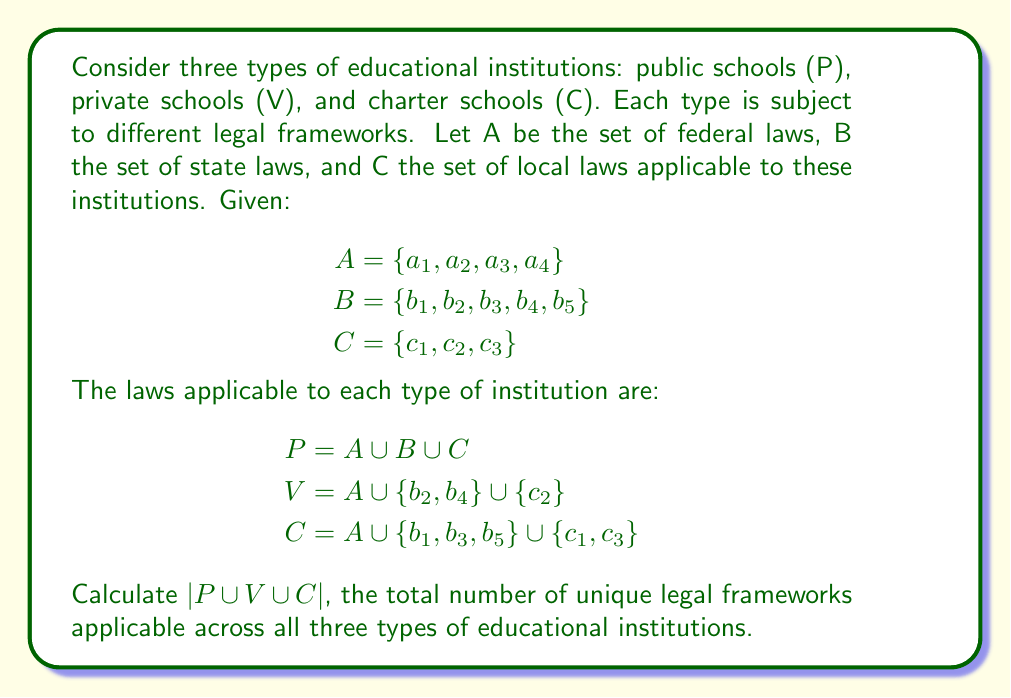What is the answer to this math problem? To solve this problem, we need to find the union of the sets P, V, and C, and then determine its cardinality. Let's break it down step by step:

1. First, let's expand each set:
   $P = \{a_1, a_2, a_3, a_4, b_1, b_2, b_3, b_4, b_5, c_1, c_2, c_3\}$
   $V = \{a_1, a_2, a_3, a_4, b_2, b_4, c_2\}$
   $C = \{a_1, a_2, a_3, a_4, b_1, b_3, b_5, c_1, c_3\}$

2. Now, we need to find $P \cup V \cup C$. This will include all unique elements from all three sets.

3. We can see that:
   - All elements of set A $(a_1, a_2, a_3, a_4)$ are in all three sets.
   - All elements of set B $(b_1, b_2, b_3, b_4, b_5)$ are included when we combine all three sets.
   - All elements of set C $(c_1, c_2, c_3)$ are also included when we combine all three sets.

4. Therefore, $P \cup V \cup C = A \cup B \cup C$

5. To calculate $|P \cup V \cup C|$, we simply need to add the cardinalities of A, B, and C:
   $|P \cup V \cup C| = |A| + |B| + |C|$

6. We know that:
   $|A| = 4$
   $|B| = 5$
   $|C| = 3$

7. So, $|P \cup V \cup C| = 4 + 5 + 3 = 12$
Answer: $|P \cup V \cup C| = 12$ 